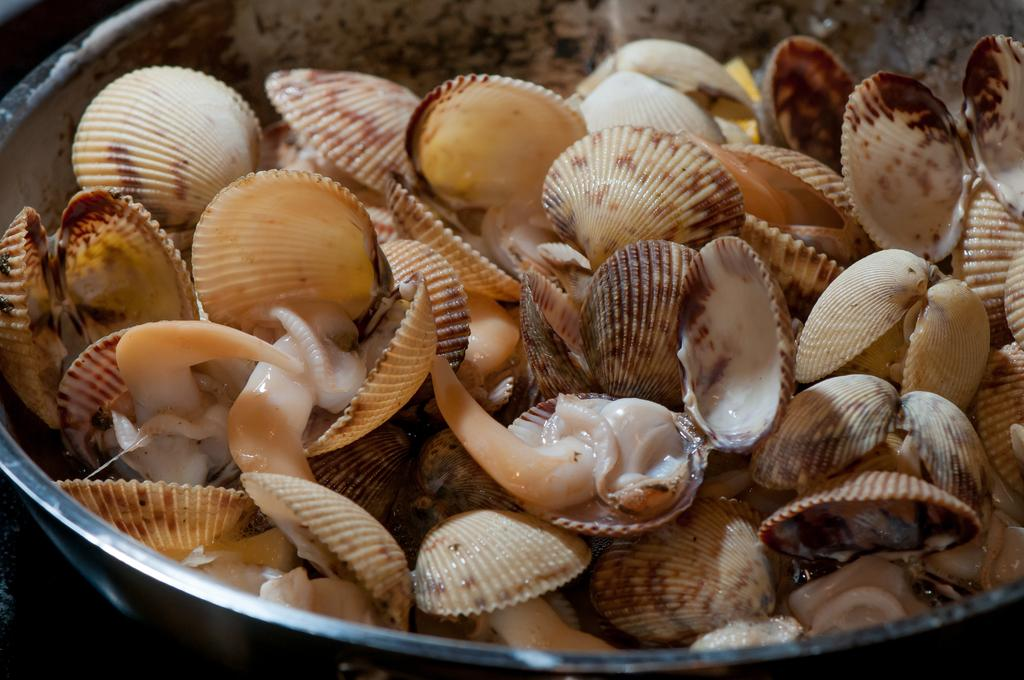What is located in the center of the image? There is a bowl in the center of the image. What is inside the bowl? The bowl contains objects and shells. Can you describe the color of the shells? The shells are in cream and brown color. How does the eye of the pollution affect the wound in the image? There is no eye, pollution, or wound present in the image. 